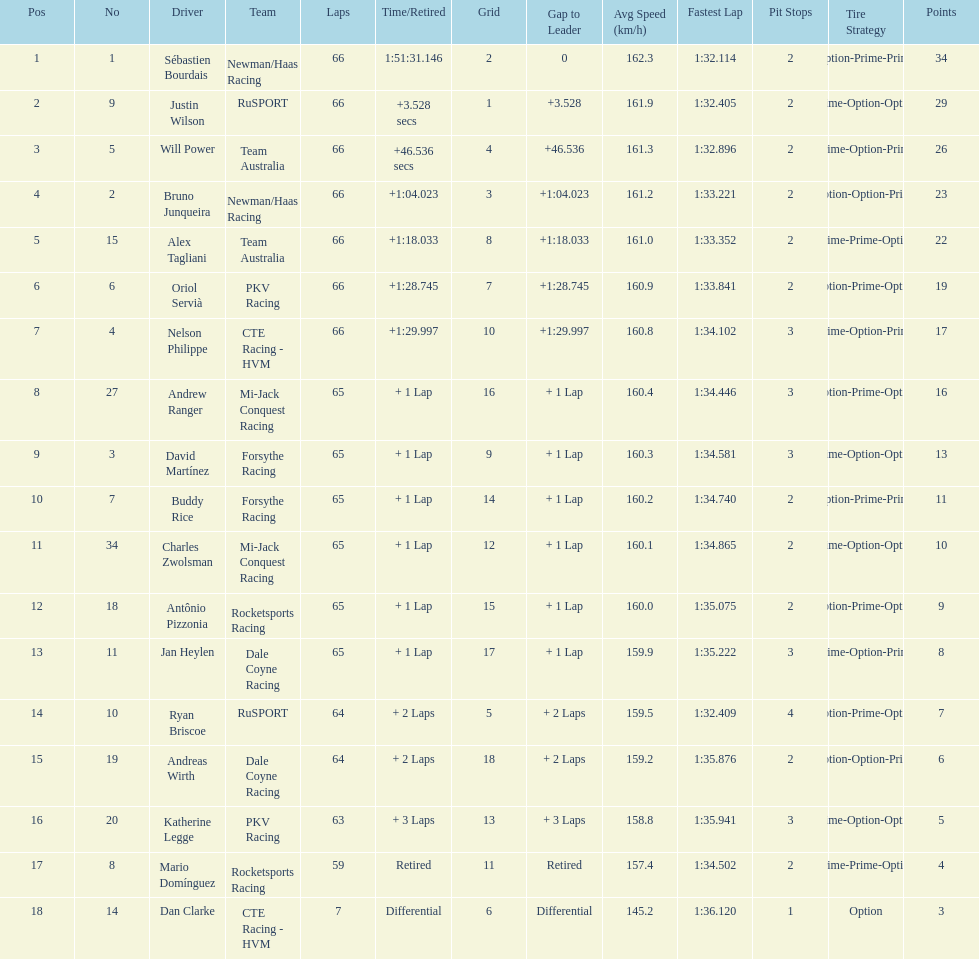What is the number of laps dan clarke completed? 7. 